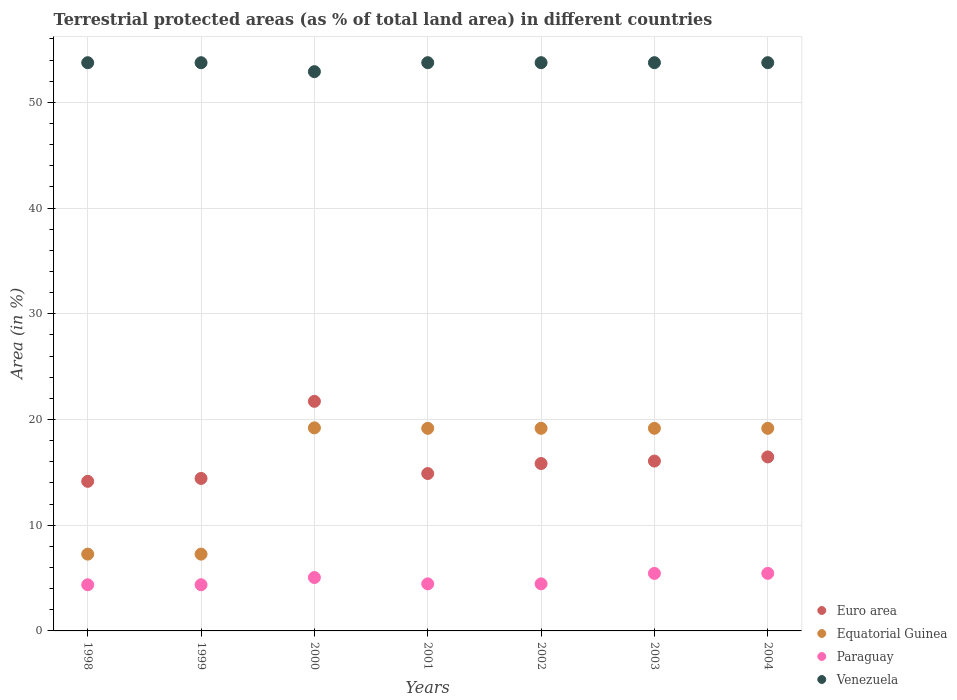Is the number of dotlines equal to the number of legend labels?
Make the answer very short. Yes. What is the percentage of terrestrial protected land in Euro area in 2002?
Provide a short and direct response. 15.83. Across all years, what is the maximum percentage of terrestrial protected land in Euro area?
Your response must be concise. 21.72. Across all years, what is the minimum percentage of terrestrial protected land in Euro area?
Keep it short and to the point. 14.15. In which year was the percentage of terrestrial protected land in Euro area minimum?
Ensure brevity in your answer.  1998. What is the total percentage of terrestrial protected land in Euro area in the graph?
Provide a succinct answer. 113.53. What is the difference between the percentage of terrestrial protected land in Paraguay in 2002 and the percentage of terrestrial protected land in Equatorial Guinea in 2003?
Make the answer very short. -14.71. What is the average percentage of terrestrial protected land in Paraguay per year?
Ensure brevity in your answer.  4.8. In the year 1998, what is the difference between the percentage of terrestrial protected land in Euro area and percentage of terrestrial protected land in Paraguay?
Keep it short and to the point. 9.78. In how many years, is the percentage of terrestrial protected land in Euro area greater than 4 %?
Offer a very short reply. 7. What is the ratio of the percentage of terrestrial protected land in Venezuela in 1999 to that in 2000?
Your answer should be compact. 1.02. Is the percentage of terrestrial protected land in Venezuela in 2001 less than that in 2004?
Provide a short and direct response. Yes. What is the difference between the highest and the second highest percentage of terrestrial protected land in Paraguay?
Ensure brevity in your answer.  0. What is the difference between the highest and the lowest percentage of terrestrial protected land in Paraguay?
Give a very brief answer. 1.08. Is the sum of the percentage of terrestrial protected land in Euro area in 1999 and 2001 greater than the maximum percentage of terrestrial protected land in Equatorial Guinea across all years?
Your answer should be compact. Yes. Does the percentage of terrestrial protected land in Euro area monotonically increase over the years?
Provide a succinct answer. No. Is the percentage of terrestrial protected land in Paraguay strictly less than the percentage of terrestrial protected land in Venezuela over the years?
Make the answer very short. Yes. What is the difference between two consecutive major ticks on the Y-axis?
Ensure brevity in your answer.  10. Are the values on the major ticks of Y-axis written in scientific E-notation?
Your answer should be compact. No. Where does the legend appear in the graph?
Your response must be concise. Bottom right. How many legend labels are there?
Ensure brevity in your answer.  4. How are the legend labels stacked?
Keep it short and to the point. Vertical. What is the title of the graph?
Offer a terse response. Terrestrial protected areas (as % of total land area) in different countries. What is the label or title of the X-axis?
Give a very brief answer. Years. What is the label or title of the Y-axis?
Ensure brevity in your answer.  Area (in %). What is the Area (in %) in Euro area in 1998?
Your response must be concise. 14.15. What is the Area (in %) of Equatorial Guinea in 1998?
Give a very brief answer. 7.26. What is the Area (in %) in Paraguay in 1998?
Keep it short and to the point. 4.37. What is the Area (in %) in Venezuela in 1998?
Give a very brief answer. 53.75. What is the Area (in %) of Euro area in 1999?
Offer a terse response. 14.42. What is the Area (in %) of Equatorial Guinea in 1999?
Provide a short and direct response. 7.26. What is the Area (in %) in Paraguay in 1999?
Offer a very short reply. 4.37. What is the Area (in %) of Venezuela in 1999?
Provide a succinct answer. 53.75. What is the Area (in %) of Euro area in 2000?
Your answer should be very brief. 21.72. What is the Area (in %) of Equatorial Guinea in 2000?
Offer a terse response. 19.21. What is the Area (in %) in Paraguay in 2000?
Your response must be concise. 5.05. What is the Area (in %) of Venezuela in 2000?
Make the answer very short. 52.9. What is the Area (in %) in Euro area in 2001?
Ensure brevity in your answer.  14.89. What is the Area (in %) in Equatorial Guinea in 2001?
Provide a short and direct response. 19.16. What is the Area (in %) in Paraguay in 2001?
Keep it short and to the point. 4.45. What is the Area (in %) in Venezuela in 2001?
Give a very brief answer. 53.75. What is the Area (in %) in Euro area in 2002?
Offer a very short reply. 15.83. What is the Area (in %) of Equatorial Guinea in 2002?
Keep it short and to the point. 19.16. What is the Area (in %) in Paraguay in 2002?
Your answer should be very brief. 4.45. What is the Area (in %) in Venezuela in 2002?
Your answer should be compact. 53.75. What is the Area (in %) in Euro area in 2003?
Provide a succinct answer. 16.07. What is the Area (in %) in Equatorial Guinea in 2003?
Ensure brevity in your answer.  19.16. What is the Area (in %) of Paraguay in 2003?
Your answer should be very brief. 5.44. What is the Area (in %) in Venezuela in 2003?
Your answer should be compact. 53.75. What is the Area (in %) of Euro area in 2004?
Your answer should be compact. 16.46. What is the Area (in %) of Equatorial Guinea in 2004?
Your answer should be compact. 19.16. What is the Area (in %) of Paraguay in 2004?
Offer a terse response. 5.44. What is the Area (in %) of Venezuela in 2004?
Keep it short and to the point. 53.75. Across all years, what is the maximum Area (in %) in Euro area?
Provide a succinct answer. 21.72. Across all years, what is the maximum Area (in %) of Equatorial Guinea?
Make the answer very short. 19.21. Across all years, what is the maximum Area (in %) of Paraguay?
Give a very brief answer. 5.44. Across all years, what is the maximum Area (in %) of Venezuela?
Keep it short and to the point. 53.75. Across all years, what is the minimum Area (in %) of Euro area?
Your response must be concise. 14.15. Across all years, what is the minimum Area (in %) of Equatorial Guinea?
Provide a short and direct response. 7.26. Across all years, what is the minimum Area (in %) in Paraguay?
Your response must be concise. 4.37. Across all years, what is the minimum Area (in %) in Venezuela?
Your response must be concise. 52.9. What is the total Area (in %) of Euro area in the graph?
Your answer should be compact. 113.53. What is the total Area (in %) in Equatorial Guinea in the graph?
Provide a short and direct response. 110.39. What is the total Area (in %) in Paraguay in the graph?
Give a very brief answer. 33.57. What is the total Area (in %) of Venezuela in the graph?
Keep it short and to the point. 375.39. What is the difference between the Area (in %) of Euro area in 1998 and that in 1999?
Your answer should be very brief. -0.27. What is the difference between the Area (in %) of Paraguay in 1998 and that in 1999?
Offer a terse response. 0. What is the difference between the Area (in %) in Euro area in 1998 and that in 2000?
Your answer should be compact. -7.57. What is the difference between the Area (in %) of Equatorial Guinea in 1998 and that in 2000?
Your response must be concise. -11.94. What is the difference between the Area (in %) of Paraguay in 1998 and that in 2000?
Your response must be concise. -0.68. What is the difference between the Area (in %) in Venezuela in 1998 and that in 2000?
Provide a short and direct response. 0.85. What is the difference between the Area (in %) of Euro area in 1998 and that in 2001?
Your answer should be very brief. -0.74. What is the difference between the Area (in %) in Equatorial Guinea in 1998 and that in 2001?
Your answer should be very brief. -11.9. What is the difference between the Area (in %) of Paraguay in 1998 and that in 2001?
Offer a terse response. -0.08. What is the difference between the Area (in %) in Venezuela in 1998 and that in 2001?
Ensure brevity in your answer.  -0. What is the difference between the Area (in %) in Euro area in 1998 and that in 2002?
Make the answer very short. -1.69. What is the difference between the Area (in %) in Equatorial Guinea in 1998 and that in 2002?
Your answer should be compact. -11.9. What is the difference between the Area (in %) in Paraguay in 1998 and that in 2002?
Offer a very short reply. -0.08. What is the difference between the Area (in %) of Venezuela in 1998 and that in 2002?
Offer a very short reply. -0. What is the difference between the Area (in %) of Euro area in 1998 and that in 2003?
Ensure brevity in your answer.  -1.92. What is the difference between the Area (in %) of Equatorial Guinea in 1998 and that in 2003?
Provide a succinct answer. -11.9. What is the difference between the Area (in %) in Paraguay in 1998 and that in 2003?
Your answer should be very brief. -1.07. What is the difference between the Area (in %) of Venezuela in 1998 and that in 2003?
Offer a terse response. -0. What is the difference between the Area (in %) of Euro area in 1998 and that in 2004?
Ensure brevity in your answer.  -2.31. What is the difference between the Area (in %) in Equatorial Guinea in 1998 and that in 2004?
Provide a short and direct response. -11.9. What is the difference between the Area (in %) of Paraguay in 1998 and that in 2004?
Offer a very short reply. -1.08. What is the difference between the Area (in %) in Venezuela in 1998 and that in 2004?
Your response must be concise. -0. What is the difference between the Area (in %) of Euro area in 1999 and that in 2000?
Give a very brief answer. -7.29. What is the difference between the Area (in %) in Equatorial Guinea in 1999 and that in 2000?
Provide a short and direct response. -11.94. What is the difference between the Area (in %) of Paraguay in 1999 and that in 2000?
Your response must be concise. -0.68. What is the difference between the Area (in %) of Venezuela in 1999 and that in 2000?
Your response must be concise. 0.85. What is the difference between the Area (in %) of Euro area in 1999 and that in 2001?
Your answer should be compact. -0.46. What is the difference between the Area (in %) in Equatorial Guinea in 1999 and that in 2001?
Provide a succinct answer. -11.9. What is the difference between the Area (in %) of Paraguay in 1999 and that in 2001?
Offer a very short reply. -0.08. What is the difference between the Area (in %) in Venezuela in 1999 and that in 2001?
Your response must be concise. -0. What is the difference between the Area (in %) in Euro area in 1999 and that in 2002?
Offer a very short reply. -1.41. What is the difference between the Area (in %) of Equatorial Guinea in 1999 and that in 2002?
Ensure brevity in your answer.  -11.9. What is the difference between the Area (in %) in Paraguay in 1999 and that in 2002?
Your answer should be compact. -0.08. What is the difference between the Area (in %) of Venezuela in 1999 and that in 2002?
Make the answer very short. -0. What is the difference between the Area (in %) of Euro area in 1999 and that in 2003?
Make the answer very short. -1.64. What is the difference between the Area (in %) of Equatorial Guinea in 1999 and that in 2003?
Make the answer very short. -11.9. What is the difference between the Area (in %) of Paraguay in 1999 and that in 2003?
Provide a succinct answer. -1.07. What is the difference between the Area (in %) in Venezuela in 1999 and that in 2003?
Offer a terse response. -0. What is the difference between the Area (in %) in Euro area in 1999 and that in 2004?
Ensure brevity in your answer.  -2.04. What is the difference between the Area (in %) in Equatorial Guinea in 1999 and that in 2004?
Make the answer very short. -11.9. What is the difference between the Area (in %) of Paraguay in 1999 and that in 2004?
Your response must be concise. -1.08. What is the difference between the Area (in %) in Venezuela in 1999 and that in 2004?
Your answer should be very brief. -0. What is the difference between the Area (in %) of Euro area in 2000 and that in 2001?
Give a very brief answer. 6.83. What is the difference between the Area (in %) of Equatorial Guinea in 2000 and that in 2001?
Ensure brevity in your answer.  0.04. What is the difference between the Area (in %) in Paraguay in 2000 and that in 2001?
Your answer should be compact. 0.6. What is the difference between the Area (in %) in Venezuela in 2000 and that in 2001?
Your answer should be compact. -0.85. What is the difference between the Area (in %) in Euro area in 2000 and that in 2002?
Your response must be concise. 5.88. What is the difference between the Area (in %) in Equatorial Guinea in 2000 and that in 2002?
Give a very brief answer. 0.04. What is the difference between the Area (in %) of Paraguay in 2000 and that in 2002?
Your response must be concise. 0.6. What is the difference between the Area (in %) of Venezuela in 2000 and that in 2002?
Provide a succinct answer. -0.85. What is the difference between the Area (in %) in Euro area in 2000 and that in 2003?
Ensure brevity in your answer.  5.65. What is the difference between the Area (in %) of Equatorial Guinea in 2000 and that in 2003?
Offer a terse response. 0.04. What is the difference between the Area (in %) of Paraguay in 2000 and that in 2003?
Keep it short and to the point. -0.39. What is the difference between the Area (in %) in Venezuela in 2000 and that in 2003?
Provide a succinct answer. -0.85. What is the difference between the Area (in %) of Euro area in 2000 and that in 2004?
Provide a succinct answer. 5.26. What is the difference between the Area (in %) of Equatorial Guinea in 2000 and that in 2004?
Make the answer very short. 0.04. What is the difference between the Area (in %) of Paraguay in 2000 and that in 2004?
Keep it short and to the point. -0.39. What is the difference between the Area (in %) in Venezuela in 2000 and that in 2004?
Provide a short and direct response. -0.85. What is the difference between the Area (in %) of Euro area in 2001 and that in 2002?
Give a very brief answer. -0.95. What is the difference between the Area (in %) in Equatorial Guinea in 2001 and that in 2002?
Your response must be concise. -0. What is the difference between the Area (in %) in Paraguay in 2001 and that in 2002?
Offer a very short reply. 0. What is the difference between the Area (in %) in Euro area in 2001 and that in 2003?
Offer a very short reply. -1.18. What is the difference between the Area (in %) in Equatorial Guinea in 2001 and that in 2003?
Provide a succinct answer. -0. What is the difference between the Area (in %) of Paraguay in 2001 and that in 2003?
Offer a very short reply. -0.99. What is the difference between the Area (in %) in Euro area in 2001 and that in 2004?
Your answer should be very brief. -1.57. What is the difference between the Area (in %) of Equatorial Guinea in 2001 and that in 2004?
Keep it short and to the point. -0. What is the difference between the Area (in %) in Paraguay in 2001 and that in 2004?
Provide a succinct answer. -0.99. What is the difference between the Area (in %) of Venezuela in 2001 and that in 2004?
Your answer should be very brief. -0. What is the difference between the Area (in %) of Euro area in 2002 and that in 2003?
Provide a succinct answer. -0.23. What is the difference between the Area (in %) in Paraguay in 2002 and that in 2003?
Keep it short and to the point. -0.99. What is the difference between the Area (in %) of Venezuela in 2002 and that in 2003?
Your response must be concise. 0. What is the difference between the Area (in %) of Euro area in 2002 and that in 2004?
Keep it short and to the point. -0.62. What is the difference between the Area (in %) in Paraguay in 2002 and that in 2004?
Your answer should be very brief. -0.99. What is the difference between the Area (in %) in Venezuela in 2002 and that in 2004?
Keep it short and to the point. 0. What is the difference between the Area (in %) of Euro area in 2003 and that in 2004?
Make the answer very short. -0.39. What is the difference between the Area (in %) of Paraguay in 2003 and that in 2004?
Your answer should be compact. -0. What is the difference between the Area (in %) in Euro area in 1998 and the Area (in %) in Equatorial Guinea in 1999?
Offer a very short reply. 6.88. What is the difference between the Area (in %) of Euro area in 1998 and the Area (in %) of Paraguay in 1999?
Your response must be concise. 9.78. What is the difference between the Area (in %) of Euro area in 1998 and the Area (in %) of Venezuela in 1999?
Offer a terse response. -39.6. What is the difference between the Area (in %) in Equatorial Guinea in 1998 and the Area (in %) in Paraguay in 1999?
Your answer should be compact. 2.9. What is the difference between the Area (in %) of Equatorial Guinea in 1998 and the Area (in %) of Venezuela in 1999?
Make the answer very short. -46.48. What is the difference between the Area (in %) of Paraguay in 1998 and the Area (in %) of Venezuela in 1999?
Make the answer very short. -49.38. What is the difference between the Area (in %) of Euro area in 1998 and the Area (in %) of Equatorial Guinea in 2000?
Provide a short and direct response. -5.06. What is the difference between the Area (in %) of Euro area in 1998 and the Area (in %) of Paraguay in 2000?
Give a very brief answer. 9.1. What is the difference between the Area (in %) in Euro area in 1998 and the Area (in %) in Venezuela in 2000?
Your answer should be very brief. -38.75. What is the difference between the Area (in %) in Equatorial Guinea in 1998 and the Area (in %) in Paraguay in 2000?
Provide a succinct answer. 2.21. What is the difference between the Area (in %) in Equatorial Guinea in 1998 and the Area (in %) in Venezuela in 2000?
Offer a very short reply. -45.64. What is the difference between the Area (in %) in Paraguay in 1998 and the Area (in %) in Venezuela in 2000?
Give a very brief answer. -48.53. What is the difference between the Area (in %) in Euro area in 1998 and the Area (in %) in Equatorial Guinea in 2001?
Keep it short and to the point. -5.01. What is the difference between the Area (in %) of Euro area in 1998 and the Area (in %) of Paraguay in 2001?
Your response must be concise. 9.7. What is the difference between the Area (in %) in Euro area in 1998 and the Area (in %) in Venezuela in 2001?
Keep it short and to the point. -39.6. What is the difference between the Area (in %) of Equatorial Guinea in 1998 and the Area (in %) of Paraguay in 2001?
Provide a succinct answer. 2.81. What is the difference between the Area (in %) in Equatorial Guinea in 1998 and the Area (in %) in Venezuela in 2001?
Your response must be concise. -46.49. What is the difference between the Area (in %) of Paraguay in 1998 and the Area (in %) of Venezuela in 2001?
Ensure brevity in your answer.  -49.38. What is the difference between the Area (in %) in Euro area in 1998 and the Area (in %) in Equatorial Guinea in 2002?
Your answer should be very brief. -5.02. What is the difference between the Area (in %) of Euro area in 1998 and the Area (in %) of Paraguay in 2002?
Your answer should be very brief. 9.7. What is the difference between the Area (in %) of Euro area in 1998 and the Area (in %) of Venezuela in 2002?
Provide a short and direct response. -39.6. What is the difference between the Area (in %) in Equatorial Guinea in 1998 and the Area (in %) in Paraguay in 2002?
Ensure brevity in your answer.  2.81. What is the difference between the Area (in %) in Equatorial Guinea in 1998 and the Area (in %) in Venezuela in 2002?
Offer a terse response. -46.49. What is the difference between the Area (in %) in Paraguay in 1998 and the Area (in %) in Venezuela in 2002?
Your response must be concise. -49.38. What is the difference between the Area (in %) in Euro area in 1998 and the Area (in %) in Equatorial Guinea in 2003?
Your answer should be very brief. -5.02. What is the difference between the Area (in %) in Euro area in 1998 and the Area (in %) in Paraguay in 2003?
Make the answer very short. 8.71. What is the difference between the Area (in %) in Euro area in 1998 and the Area (in %) in Venezuela in 2003?
Offer a terse response. -39.6. What is the difference between the Area (in %) of Equatorial Guinea in 1998 and the Area (in %) of Paraguay in 2003?
Keep it short and to the point. 1.82. What is the difference between the Area (in %) of Equatorial Guinea in 1998 and the Area (in %) of Venezuela in 2003?
Provide a succinct answer. -46.49. What is the difference between the Area (in %) in Paraguay in 1998 and the Area (in %) in Venezuela in 2003?
Give a very brief answer. -49.38. What is the difference between the Area (in %) in Euro area in 1998 and the Area (in %) in Equatorial Guinea in 2004?
Provide a short and direct response. -5.02. What is the difference between the Area (in %) in Euro area in 1998 and the Area (in %) in Paraguay in 2004?
Your response must be concise. 8.7. What is the difference between the Area (in %) in Euro area in 1998 and the Area (in %) in Venezuela in 2004?
Keep it short and to the point. -39.6. What is the difference between the Area (in %) of Equatorial Guinea in 1998 and the Area (in %) of Paraguay in 2004?
Offer a terse response. 1.82. What is the difference between the Area (in %) in Equatorial Guinea in 1998 and the Area (in %) in Venezuela in 2004?
Your response must be concise. -46.49. What is the difference between the Area (in %) of Paraguay in 1998 and the Area (in %) of Venezuela in 2004?
Make the answer very short. -49.38. What is the difference between the Area (in %) of Euro area in 1999 and the Area (in %) of Equatorial Guinea in 2000?
Ensure brevity in your answer.  -4.79. What is the difference between the Area (in %) in Euro area in 1999 and the Area (in %) in Paraguay in 2000?
Give a very brief answer. 9.37. What is the difference between the Area (in %) of Euro area in 1999 and the Area (in %) of Venezuela in 2000?
Offer a terse response. -38.48. What is the difference between the Area (in %) in Equatorial Guinea in 1999 and the Area (in %) in Paraguay in 2000?
Provide a short and direct response. 2.21. What is the difference between the Area (in %) of Equatorial Guinea in 1999 and the Area (in %) of Venezuela in 2000?
Provide a short and direct response. -45.64. What is the difference between the Area (in %) of Paraguay in 1999 and the Area (in %) of Venezuela in 2000?
Offer a terse response. -48.53. What is the difference between the Area (in %) in Euro area in 1999 and the Area (in %) in Equatorial Guinea in 2001?
Your answer should be very brief. -4.74. What is the difference between the Area (in %) in Euro area in 1999 and the Area (in %) in Paraguay in 2001?
Keep it short and to the point. 9.97. What is the difference between the Area (in %) in Euro area in 1999 and the Area (in %) in Venezuela in 2001?
Ensure brevity in your answer.  -39.33. What is the difference between the Area (in %) of Equatorial Guinea in 1999 and the Area (in %) of Paraguay in 2001?
Provide a short and direct response. 2.81. What is the difference between the Area (in %) in Equatorial Guinea in 1999 and the Area (in %) in Venezuela in 2001?
Give a very brief answer. -46.49. What is the difference between the Area (in %) of Paraguay in 1999 and the Area (in %) of Venezuela in 2001?
Offer a very short reply. -49.38. What is the difference between the Area (in %) of Euro area in 1999 and the Area (in %) of Equatorial Guinea in 2002?
Your answer should be compact. -4.74. What is the difference between the Area (in %) of Euro area in 1999 and the Area (in %) of Paraguay in 2002?
Offer a very short reply. 9.97. What is the difference between the Area (in %) in Euro area in 1999 and the Area (in %) in Venezuela in 2002?
Make the answer very short. -39.33. What is the difference between the Area (in %) of Equatorial Guinea in 1999 and the Area (in %) of Paraguay in 2002?
Keep it short and to the point. 2.81. What is the difference between the Area (in %) in Equatorial Guinea in 1999 and the Area (in %) in Venezuela in 2002?
Provide a short and direct response. -46.49. What is the difference between the Area (in %) in Paraguay in 1999 and the Area (in %) in Venezuela in 2002?
Keep it short and to the point. -49.38. What is the difference between the Area (in %) of Euro area in 1999 and the Area (in %) of Equatorial Guinea in 2003?
Provide a short and direct response. -4.74. What is the difference between the Area (in %) of Euro area in 1999 and the Area (in %) of Paraguay in 2003?
Provide a short and direct response. 8.98. What is the difference between the Area (in %) in Euro area in 1999 and the Area (in %) in Venezuela in 2003?
Ensure brevity in your answer.  -39.33. What is the difference between the Area (in %) of Equatorial Guinea in 1999 and the Area (in %) of Paraguay in 2003?
Offer a terse response. 1.82. What is the difference between the Area (in %) of Equatorial Guinea in 1999 and the Area (in %) of Venezuela in 2003?
Give a very brief answer. -46.49. What is the difference between the Area (in %) of Paraguay in 1999 and the Area (in %) of Venezuela in 2003?
Keep it short and to the point. -49.38. What is the difference between the Area (in %) in Euro area in 1999 and the Area (in %) in Equatorial Guinea in 2004?
Provide a short and direct response. -4.74. What is the difference between the Area (in %) in Euro area in 1999 and the Area (in %) in Paraguay in 2004?
Your response must be concise. 8.98. What is the difference between the Area (in %) in Euro area in 1999 and the Area (in %) in Venezuela in 2004?
Make the answer very short. -39.33. What is the difference between the Area (in %) of Equatorial Guinea in 1999 and the Area (in %) of Paraguay in 2004?
Make the answer very short. 1.82. What is the difference between the Area (in %) of Equatorial Guinea in 1999 and the Area (in %) of Venezuela in 2004?
Ensure brevity in your answer.  -46.49. What is the difference between the Area (in %) in Paraguay in 1999 and the Area (in %) in Venezuela in 2004?
Your answer should be very brief. -49.38. What is the difference between the Area (in %) of Euro area in 2000 and the Area (in %) of Equatorial Guinea in 2001?
Offer a terse response. 2.55. What is the difference between the Area (in %) in Euro area in 2000 and the Area (in %) in Paraguay in 2001?
Your response must be concise. 17.26. What is the difference between the Area (in %) of Euro area in 2000 and the Area (in %) of Venezuela in 2001?
Offer a terse response. -32.03. What is the difference between the Area (in %) in Equatorial Guinea in 2000 and the Area (in %) in Paraguay in 2001?
Make the answer very short. 14.76. What is the difference between the Area (in %) in Equatorial Guinea in 2000 and the Area (in %) in Venezuela in 2001?
Your answer should be very brief. -34.54. What is the difference between the Area (in %) in Paraguay in 2000 and the Area (in %) in Venezuela in 2001?
Provide a succinct answer. -48.7. What is the difference between the Area (in %) in Euro area in 2000 and the Area (in %) in Equatorial Guinea in 2002?
Ensure brevity in your answer.  2.55. What is the difference between the Area (in %) of Euro area in 2000 and the Area (in %) of Paraguay in 2002?
Your answer should be very brief. 17.26. What is the difference between the Area (in %) in Euro area in 2000 and the Area (in %) in Venezuela in 2002?
Make the answer very short. -32.03. What is the difference between the Area (in %) of Equatorial Guinea in 2000 and the Area (in %) of Paraguay in 2002?
Your answer should be very brief. 14.76. What is the difference between the Area (in %) of Equatorial Guinea in 2000 and the Area (in %) of Venezuela in 2002?
Your response must be concise. -34.54. What is the difference between the Area (in %) in Paraguay in 2000 and the Area (in %) in Venezuela in 2002?
Provide a short and direct response. -48.7. What is the difference between the Area (in %) of Euro area in 2000 and the Area (in %) of Equatorial Guinea in 2003?
Your answer should be compact. 2.55. What is the difference between the Area (in %) of Euro area in 2000 and the Area (in %) of Paraguay in 2003?
Ensure brevity in your answer.  16.28. What is the difference between the Area (in %) in Euro area in 2000 and the Area (in %) in Venezuela in 2003?
Your answer should be compact. -32.03. What is the difference between the Area (in %) in Equatorial Guinea in 2000 and the Area (in %) in Paraguay in 2003?
Make the answer very short. 13.77. What is the difference between the Area (in %) in Equatorial Guinea in 2000 and the Area (in %) in Venezuela in 2003?
Make the answer very short. -34.54. What is the difference between the Area (in %) in Paraguay in 2000 and the Area (in %) in Venezuela in 2003?
Provide a succinct answer. -48.7. What is the difference between the Area (in %) of Euro area in 2000 and the Area (in %) of Equatorial Guinea in 2004?
Your response must be concise. 2.55. What is the difference between the Area (in %) of Euro area in 2000 and the Area (in %) of Paraguay in 2004?
Your answer should be compact. 16.27. What is the difference between the Area (in %) of Euro area in 2000 and the Area (in %) of Venezuela in 2004?
Provide a succinct answer. -32.03. What is the difference between the Area (in %) of Equatorial Guinea in 2000 and the Area (in %) of Paraguay in 2004?
Offer a very short reply. 13.76. What is the difference between the Area (in %) in Equatorial Guinea in 2000 and the Area (in %) in Venezuela in 2004?
Provide a succinct answer. -34.54. What is the difference between the Area (in %) of Paraguay in 2000 and the Area (in %) of Venezuela in 2004?
Give a very brief answer. -48.7. What is the difference between the Area (in %) of Euro area in 2001 and the Area (in %) of Equatorial Guinea in 2002?
Offer a terse response. -4.28. What is the difference between the Area (in %) in Euro area in 2001 and the Area (in %) in Paraguay in 2002?
Offer a very short reply. 10.43. What is the difference between the Area (in %) of Euro area in 2001 and the Area (in %) of Venezuela in 2002?
Provide a short and direct response. -38.86. What is the difference between the Area (in %) in Equatorial Guinea in 2001 and the Area (in %) in Paraguay in 2002?
Your answer should be compact. 14.71. What is the difference between the Area (in %) of Equatorial Guinea in 2001 and the Area (in %) of Venezuela in 2002?
Provide a short and direct response. -34.59. What is the difference between the Area (in %) in Paraguay in 2001 and the Area (in %) in Venezuela in 2002?
Your answer should be very brief. -49.3. What is the difference between the Area (in %) of Euro area in 2001 and the Area (in %) of Equatorial Guinea in 2003?
Provide a succinct answer. -4.28. What is the difference between the Area (in %) of Euro area in 2001 and the Area (in %) of Paraguay in 2003?
Your answer should be very brief. 9.45. What is the difference between the Area (in %) in Euro area in 2001 and the Area (in %) in Venezuela in 2003?
Your response must be concise. -38.86. What is the difference between the Area (in %) in Equatorial Guinea in 2001 and the Area (in %) in Paraguay in 2003?
Ensure brevity in your answer.  13.72. What is the difference between the Area (in %) in Equatorial Guinea in 2001 and the Area (in %) in Venezuela in 2003?
Your answer should be compact. -34.59. What is the difference between the Area (in %) in Paraguay in 2001 and the Area (in %) in Venezuela in 2003?
Keep it short and to the point. -49.3. What is the difference between the Area (in %) in Euro area in 2001 and the Area (in %) in Equatorial Guinea in 2004?
Provide a short and direct response. -4.28. What is the difference between the Area (in %) of Euro area in 2001 and the Area (in %) of Paraguay in 2004?
Keep it short and to the point. 9.44. What is the difference between the Area (in %) in Euro area in 2001 and the Area (in %) in Venezuela in 2004?
Your answer should be compact. -38.86. What is the difference between the Area (in %) of Equatorial Guinea in 2001 and the Area (in %) of Paraguay in 2004?
Give a very brief answer. 13.72. What is the difference between the Area (in %) of Equatorial Guinea in 2001 and the Area (in %) of Venezuela in 2004?
Offer a terse response. -34.59. What is the difference between the Area (in %) in Paraguay in 2001 and the Area (in %) in Venezuela in 2004?
Give a very brief answer. -49.3. What is the difference between the Area (in %) in Euro area in 2002 and the Area (in %) in Equatorial Guinea in 2003?
Provide a short and direct response. -3.33. What is the difference between the Area (in %) in Euro area in 2002 and the Area (in %) in Paraguay in 2003?
Provide a short and direct response. 10.39. What is the difference between the Area (in %) of Euro area in 2002 and the Area (in %) of Venezuela in 2003?
Your answer should be compact. -37.92. What is the difference between the Area (in %) in Equatorial Guinea in 2002 and the Area (in %) in Paraguay in 2003?
Provide a succinct answer. 13.72. What is the difference between the Area (in %) in Equatorial Guinea in 2002 and the Area (in %) in Venezuela in 2003?
Offer a terse response. -34.59. What is the difference between the Area (in %) in Paraguay in 2002 and the Area (in %) in Venezuela in 2003?
Give a very brief answer. -49.3. What is the difference between the Area (in %) in Euro area in 2002 and the Area (in %) in Equatorial Guinea in 2004?
Your answer should be very brief. -3.33. What is the difference between the Area (in %) of Euro area in 2002 and the Area (in %) of Paraguay in 2004?
Your answer should be compact. 10.39. What is the difference between the Area (in %) in Euro area in 2002 and the Area (in %) in Venezuela in 2004?
Offer a very short reply. -37.92. What is the difference between the Area (in %) in Equatorial Guinea in 2002 and the Area (in %) in Paraguay in 2004?
Your response must be concise. 13.72. What is the difference between the Area (in %) in Equatorial Guinea in 2002 and the Area (in %) in Venezuela in 2004?
Ensure brevity in your answer.  -34.59. What is the difference between the Area (in %) of Paraguay in 2002 and the Area (in %) of Venezuela in 2004?
Offer a terse response. -49.3. What is the difference between the Area (in %) of Euro area in 2003 and the Area (in %) of Equatorial Guinea in 2004?
Offer a terse response. -3.1. What is the difference between the Area (in %) of Euro area in 2003 and the Area (in %) of Paraguay in 2004?
Provide a short and direct response. 10.62. What is the difference between the Area (in %) of Euro area in 2003 and the Area (in %) of Venezuela in 2004?
Make the answer very short. -37.68. What is the difference between the Area (in %) of Equatorial Guinea in 2003 and the Area (in %) of Paraguay in 2004?
Give a very brief answer. 13.72. What is the difference between the Area (in %) of Equatorial Guinea in 2003 and the Area (in %) of Venezuela in 2004?
Ensure brevity in your answer.  -34.59. What is the difference between the Area (in %) of Paraguay in 2003 and the Area (in %) of Venezuela in 2004?
Ensure brevity in your answer.  -48.31. What is the average Area (in %) in Euro area per year?
Provide a succinct answer. 16.22. What is the average Area (in %) in Equatorial Guinea per year?
Your answer should be compact. 15.77. What is the average Area (in %) in Paraguay per year?
Keep it short and to the point. 4.8. What is the average Area (in %) of Venezuela per year?
Your answer should be very brief. 53.63. In the year 1998, what is the difference between the Area (in %) in Euro area and Area (in %) in Equatorial Guinea?
Offer a very short reply. 6.88. In the year 1998, what is the difference between the Area (in %) of Euro area and Area (in %) of Paraguay?
Your response must be concise. 9.78. In the year 1998, what is the difference between the Area (in %) in Euro area and Area (in %) in Venezuela?
Provide a succinct answer. -39.6. In the year 1998, what is the difference between the Area (in %) in Equatorial Guinea and Area (in %) in Paraguay?
Your answer should be very brief. 2.9. In the year 1998, what is the difference between the Area (in %) in Equatorial Guinea and Area (in %) in Venezuela?
Give a very brief answer. -46.48. In the year 1998, what is the difference between the Area (in %) in Paraguay and Area (in %) in Venezuela?
Your response must be concise. -49.38. In the year 1999, what is the difference between the Area (in %) of Euro area and Area (in %) of Equatorial Guinea?
Your answer should be compact. 7.16. In the year 1999, what is the difference between the Area (in %) of Euro area and Area (in %) of Paraguay?
Ensure brevity in your answer.  10.06. In the year 1999, what is the difference between the Area (in %) of Euro area and Area (in %) of Venezuela?
Offer a very short reply. -39.32. In the year 1999, what is the difference between the Area (in %) in Equatorial Guinea and Area (in %) in Paraguay?
Your answer should be compact. 2.9. In the year 1999, what is the difference between the Area (in %) in Equatorial Guinea and Area (in %) in Venezuela?
Offer a very short reply. -46.48. In the year 1999, what is the difference between the Area (in %) in Paraguay and Area (in %) in Venezuela?
Make the answer very short. -49.38. In the year 2000, what is the difference between the Area (in %) in Euro area and Area (in %) in Equatorial Guinea?
Your answer should be very brief. 2.51. In the year 2000, what is the difference between the Area (in %) in Euro area and Area (in %) in Paraguay?
Keep it short and to the point. 16.67. In the year 2000, what is the difference between the Area (in %) in Euro area and Area (in %) in Venezuela?
Your answer should be compact. -31.18. In the year 2000, what is the difference between the Area (in %) in Equatorial Guinea and Area (in %) in Paraguay?
Offer a terse response. 14.16. In the year 2000, what is the difference between the Area (in %) in Equatorial Guinea and Area (in %) in Venezuela?
Your answer should be very brief. -33.69. In the year 2000, what is the difference between the Area (in %) in Paraguay and Area (in %) in Venezuela?
Provide a succinct answer. -47.85. In the year 2001, what is the difference between the Area (in %) of Euro area and Area (in %) of Equatorial Guinea?
Provide a short and direct response. -4.28. In the year 2001, what is the difference between the Area (in %) in Euro area and Area (in %) in Paraguay?
Your response must be concise. 10.43. In the year 2001, what is the difference between the Area (in %) of Euro area and Area (in %) of Venezuela?
Provide a short and direct response. -38.86. In the year 2001, what is the difference between the Area (in %) of Equatorial Guinea and Area (in %) of Paraguay?
Make the answer very short. 14.71. In the year 2001, what is the difference between the Area (in %) in Equatorial Guinea and Area (in %) in Venezuela?
Your answer should be very brief. -34.59. In the year 2001, what is the difference between the Area (in %) of Paraguay and Area (in %) of Venezuela?
Provide a succinct answer. -49.3. In the year 2002, what is the difference between the Area (in %) in Euro area and Area (in %) in Equatorial Guinea?
Keep it short and to the point. -3.33. In the year 2002, what is the difference between the Area (in %) of Euro area and Area (in %) of Paraguay?
Provide a short and direct response. 11.38. In the year 2002, what is the difference between the Area (in %) of Euro area and Area (in %) of Venezuela?
Give a very brief answer. -37.92. In the year 2002, what is the difference between the Area (in %) in Equatorial Guinea and Area (in %) in Paraguay?
Make the answer very short. 14.71. In the year 2002, what is the difference between the Area (in %) of Equatorial Guinea and Area (in %) of Venezuela?
Offer a terse response. -34.59. In the year 2002, what is the difference between the Area (in %) of Paraguay and Area (in %) of Venezuela?
Offer a very short reply. -49.3. In the year 2003, what is the difference between the Area (in %) in Euro area and Area (in %) in Equatorial Guinea?
Keep it short and to the point. -3.1. In the year 2003, what is the difference between the Area (in %) in Euro area and Area (in %) in Paraguay?
Your response must be concise. 10.62. In the year 2003, what is the difference between the Area (in %) in Euro area and Area (in %) in Venezuela?
Your answer should be very brief. -37.68. In the year 2003, what is the difference between the Area (in %) in Equatorial Guinea and Area (in %) in Paraguay?
Offer a terse response. 13.72. In the year 2003, what is the difference between the Area (in %) of Equatorial Guinea and Area (in %) of Venezuela?
Provide a succinct answer. -34.59. In the year 2003, what is the difference between the Area (in %) in Paraguay and Area (in %) in Venezuela?
Provide a succinct answer. -48.31. In the year 2004, what is the difference between the Area (in %) of Euro area and Area (in %) of Equatorial Guinea?
Make the answer very short. -2.71. In the year 2004, what is the difference between the Area (in %) of Euro area and Area (in %) of Paraguay?
Your answer should be compact. 11.01. In the year 2004, what is the difference between the Area (in %) of Euro area and Area (in %) of Venezuela?
Offer a terse response. -37.29. In the year 2004, what is the difference between the Area (in %) in Equatorial Guinea and Area (in %) in Paraguay?
Offer a terse response. 13.72. In the year 2004, what is the difference between the Area (in %) in Equatorial Guinea and Area (in %) in Venezuela?
Provide a succinct answer. -34.59. In the year 2004, what is the difference between the Area (in %) in Paraguay and Area (in %) in Venezuela?
Your answer should be compact. -48.3. What is the ratio of the Area (in %) in Euro area in 1998 to that in 1999?
Keep it short and to the point. 0.98. What is the ratio of the Area (in %) of Equatorial Guinea in 1998 to that in 1999?
Your answer should be very brief. 1. What is the ratio of the Area (in %) in Euro area in 1998 to that in 2000?
Ensure brevity in your answer.  0.65. What is the ratio of the Area (in %) of Equatorial Guinea in 1998 to that in 2000?
Your answer should be compact. 0.38. What is the ratio of the Area (in %) in Paraguay in 1998 to that in 2000?
Provide a short and direct response. 0.86. What is the ratio of the Area (in %) of Euro area in 1998 to that in 2001?
Your response must be concise. 0.95. What is the ratio of the Area (in %) in Equatorial Guinea in 1998 to that in 2001?
Ensure brevity in your answer.  0.38. What is the ratio of the Area (in %) in Euro area in 1998 to that in 2002?
Offer a very short reply. 0.89. What is the ratio of the Area (in %) in Equatorial Guinea in 1998 to that in 2002?
Offer a terse response. 0.38. What is the ratio of the Area (in %) of Venezuela in 1998 to that in 2002?
Keep it short and to the point. 1. What is the ratio of the Area (in %) of Euro area in 1998 to that in 2003?
Keep it short and to the point. 0.88. What is the ratio of the Area (in %) of Equatorial Guinea in 1998 to that in 2003?
Provide a succinct answer. 0.38. What is the ratio of the Area (in %) in Paraguay in 1998 to that in 2003?
Your answer should be compact. 0.8. What is the ratio of the Area (in %) in Euro area in 1998 to that in 2004?
Offer a very short reply. 0.86. What is the ratio of the Area (in %) of Equatorial Guinea in 1998 to that in 2004?
Make the answer very short. 0.38. What is the ratio of the Area (in %) of Paraguay in 1998 to that in 2004?
Provide a short and direct response. 0.8. What is the ratio of the Area (in %) in Euro area in 1999 to that in 2000?
Make the answer very short. 0.66. What is the ratio of the Area (in %) of Equatorial Guinea in 1999 to that in 2000?
Offer a very short reply. 0.38. What is the ratio of the Area (in %) in Paraguay in 1999 to that in 2000?
Ensure brevity in your answer.  0.86. What is the ratio of the Area (in %) in Euro area in 1999 to that in 2001?
Offer a terse response. 0.97. What is the ratio of the Area (in %) in Equatorial Guinea in 1999 to that in 2001?
Your response must be concise. 0.38. What is the ratio of the Area (in %) of Paraguay in 1999 to that in 2001?
Your answer should be compact. 0.98. What is the ratio of the Area (in %) of Euro area in 1999 to that in 2002?
Make the answer very short. 0.91. What is the ratio of the Area (in %) in Equatorial Guinea in 1999 to that in 2002?
Make the answer very short. 0.38. What is the ratio of the Area (in %) of Paraguay in 1999 to that in 2002?
Provide a succinct answer. 0.98. What is the ratio of the Area (in %) in Venezuela in 1999 to that in 2002?
Give a very brief answer. 1. What is the ratio of the Area (in %) in Euro area in 1999 to that in 2003?
Give a very brief answer. 0.9. What is the ratio of the Area (in %) in Equatorial Guinea in 1999 to that in 2003?
Offer a very short reply. 0.38. What is the ratio of the Area (in %) in Paraguay in 1999 to that in 2003?
Provide a short and direct response. 0.8. What is the ratio of the Area (in %) of Venezuela in 1999 to that in 2003?
Offer a very short reply. 1. What is the ratio of the Area (in %) in Euro area in 1999 to that in 2004?
Your response must be concise. 0.88. What is the ratio of the Area (in %) in Equatorial Guinea in 1999 to that in 2004?
Offer a very short reply. 0.38. What is the ratio of the Area (in %) in Paraguay in 1999 to that in 2004?
Provide a short and direct response. 0.8. What is the ratio of the Area (in %) in Venezuela in 1999 to that in 2004?
Your response must be concise. 1. What is the ratio of the Area (in %) of Euro area in 2000 to that in 2001?
Offer a very short reply. 1.46. What is the ratio of the Area (in %) in Paraguay in 2000 to that in 2001?
Offer a terse response. 1.13. What is the ratio of the Area (in %) of Venezuela in 2000 to that in 2001?
Your response must be concise. 0.98. What is the ratio of the Area (in %) of Euro area in 2000 to that in 2002?
Your answer should be very brief. 1.37. What is the ratio of the Area (in %) of Equatorial Guinea in 2000 to that in 2002?
Your answer should be compact. 1. What is the ratio of the Area (in %) in Paraguay in 2000 to that in 2002?
Give a very brief answer. 1.13. What is the ratio of the Area (in %) in Venezuela in 2000 to that in 2002?
Your response must be concise. 0.98. What is the ratio of the Area (in %) in Euro area in 2000 to that in 2003?
Give a very brief answer. 1.35. What is the ratio of the Area (in %) in Equatorial Guinea in 2000 to that in 2003?
Make the answer very short. 1. What is the ratio of the Area (in %) of Paraguay in 2000 to that in 2003?
Your response must be concise. 0.93. What is the ratio of the Area (in %) in Venezuela in 2000 to that in 2003?
Your answer should be compact. 0.98. What is the ratio of the Area (in %) in Euro area in 2000 to that in 2004?
Keep it short and to the point. 1.32. What is the ratio of the Area (in %) of Paraguay in 2000 to that in 2004?
Offer a terse response. 0.93. What is the ratio of the Area (in %) of Venezuela in 2000 to that in 2004?
Provide a succinct answer. 0.98. What is the ratio of the Area (in %) of Euro area in 2001 to that in 2002?
Your response must be concise. 0.94. What is the ratio of the Area (in %) in Equatorial Guinea in 2001 to that in 2002?
Keep it short and to the point. 1. What is the ratio of the Area (in %) of Euro area in 2001 to that in 2003?
Your response must be concise. 0.93. What is the ratio of the Area (in %) of Equatorial Guinea in 2001 to that in 2003?
Ensure brevity in your answer.  1. What is the ratio of the Area (in %) in Paraguay in 2001 to that in 2003?
Offer a very short reply. 0.82. What is the ratio of the Area (in %) of Venezuela in 2001 to that in 2003?
Your answer should be compact. 1. What is the ratio of the Area (in %) in Euro area in 2001 to that in 2004?
Ensure brevity in your answer.  0.9. What is the ratio of the Area (in %) of Equatorial Guinea in 2001 to that in 2004?
Offer a very short reply. 1. What is the ratio of the Area (in %) in Paraguay in 2001 to that in 2004?
Ensure brevity in your answer.  0.82. What is the ratio of the Area (in %) of Euro area in 2002 to that in 2003?
Give a very brief answer. 0.99. What is the ratio of the Area (in %) in Equatorial Guinea in 2002 to that in 2003?
Keep it short and to the point. 1. What is the ratio of the Area (in %) in Paraguay in 2002 to that in 2003?
Provide a short and direct response. 0.82. What is the ratio of the Area (in %) of Venezuela in 2002 to that in 2003?
Your answer should be very brief. 1. What is the ratio of the Area (in %) of Euro area in 2002 to that in 2004?
Your answer should be very brief. 0.96. What is the ratio of the Area (in %) in Paraguay in 2002 to that in 2004?
Make the answer very short. 0.82. What is the ratio of the Area (in %) of Venezuela in 2002 to that in 2004?
Offer a terse response. 1. What is the ratio of the Area (in %) in Euro area in 2003 to that in 2004?
Offer a very short reply. 0.98. What is the ratio of the Area (in %) in Equatorial Guinea in 2003 to that in 2004?
Make the answer very short. 1. What is the ratio of the Area (in %) of Paraguay in 2003 to that in 2004?
Ensure brevity in your answer.  1. What is the difference between the highest and the second highest Area (in %) of Euro area?
Offer a very short reply. 5.26. What is the difference between the highest and the second highest Area (in %) in Equatorial Guinea?
Your response must be concise. 0.04. What is the difference between the highest and the second highest Area (in %) of Paraguay?
Offer a very short reply. 0. What is the difference between the highest and the lowest Area (in %) of Euro area?
Ensure brevity in your answer.  7.57. What is the difference between the highest and the lowest Area (in %) in Equatorial Guinea?
Ensure brevity in your answer.  11.94. What is the difference between the highest and the lowest Area (in %) of Paraguay?
Make the answer very short. 1.08. What is the difference between the highest and the lowest Area (in %) in Venezuela?
Offer a very short reply. 0.85. 